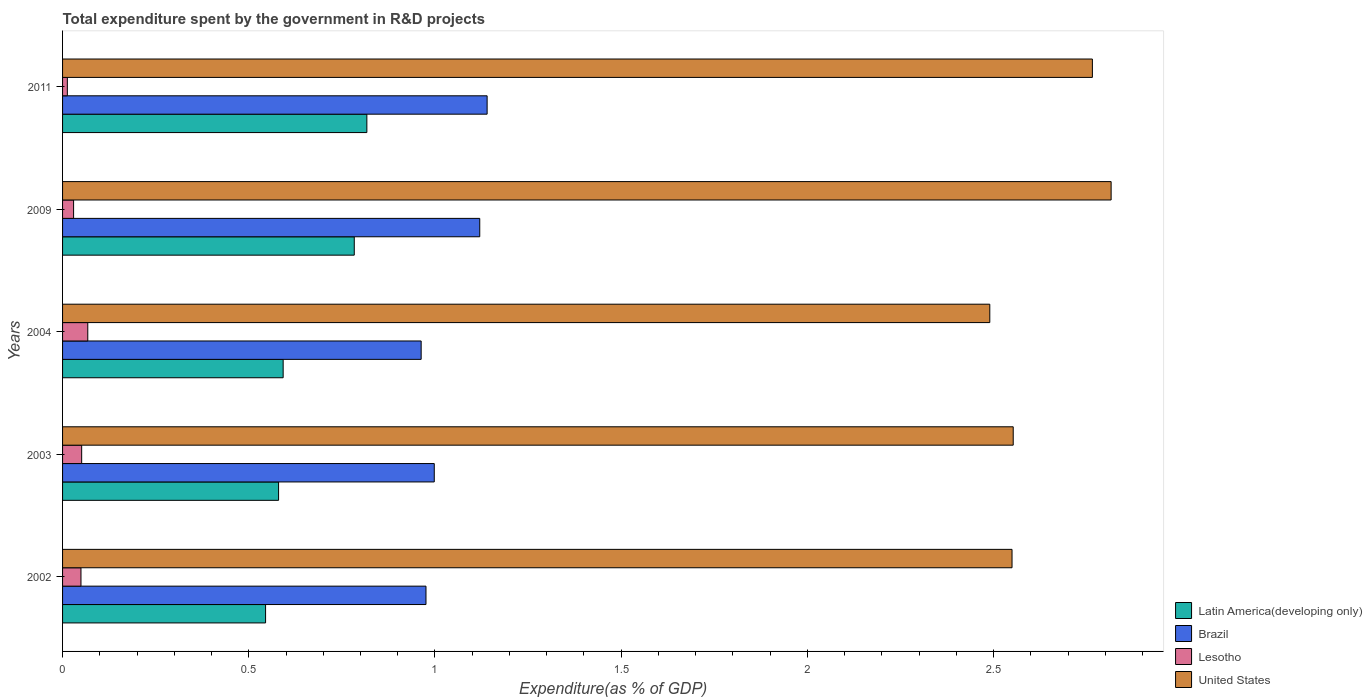How many different coloured bars are there?
Provide a short and direct response. 4. How many groups of bars are there?
Your answer should be very brief. 5. Are the number of bars per tick equal to the number of legend labels?
Offer a terse response. Yes. In how many cases, is the number of bars for a given year not equal to the number of legend labels?
Give a very brief answer. 0. What is the total expenditure spent by the government in R&D projects in Latin America(developing only) in 2004?
Provide a short and direct response. 0.59. Across all years, what is the maximum total expenditure spent by the government in R&D projects in United States?
Provide a succinct answer. 2.82. Across all years, what is the minimum total expenditure spent by the government in R&D projects in Brazil?
Offer a terse response. 0.96. In which year was the total expenditure spent by the government in R&D projects in Lesotho maximum?
Give a very brief answer. 2004. What is the total total expenditure spent by the government in R&D projects in United States in the graph?
Offer a very short reply. 13.17. What is the difference between the total expenditure spent by the government in R&D projects in United States in 2004 and that in 2011?
Your response must be concise. -0.28. What is the difference between the total expenditure spent by the government in R&D projects in United States in 2009 and the total expenditure spent by the government in R&D projects in Lesotho in 2003?
Offer a terse response. 2.76. What is the average total expenditure spent by the government in R&D projects in Brazil per year?
Make the answer very short. 1.04. In the year 2004, what is the difference between the total expenditure spent by the government in R&D projects in Brazil and total expenditure spent by the government in R&D projects in Lesotho?
Give a very brief answer. 0.9. What is the ratio of the total expenditure spent by the government in R&D projects in Brazil in 2004 to that in 2011?
Provide a succinct answer. 0.84. Is the difference between the total expenditure spent by the government in R&D projects in Brazil in 2009 and 2011 greater than the difference between the total expenditure spent by the government in R&D projects in Lesotho in 2009 and 2011?
Offer a terse response. No. What is the difference between the highest and the second highest total expenditure spent by the government in R&D projects in Lesotho?
Your response must be concise. 0.02. What is the difference between the highest and the lowest total expenditure spent by the government in R&D projects in Brazil?
Offer a very short reply. 0.18. In how many years, is the total expenditure spent by the government in R&D projects in Latin America(developing only) greater than the average total expenditure spent by the government in R&D projects in Latin America(developing only) taken over all years?
Offer a terse response. 2. Is the sum of the total expenditure spent by the government in R&D projects in Brazil in 2004 and 2011 greater than the maximum total expenditure spent by the government in R&D projects in Latin America(developing only) across all years?
Offer a terse response. Yes. What does the 3rd bar from the bottom in 2009 represents?
Your response must be concise. Lesotho. Is it the case that in every year, the sum of the total expenditure spent by the government in R&D projects in Lesotho and total expenditure spent by the government in R&D projects in United States is greater than the total expenditure spent by the government in R&D projects in Latin America(developing only)?
Offer a terse response. Yes. How many years are there in the graph?
Ensure brevity in your answer.  5. Does the graph contain any zero values?
Offer a terse response. No. Does the graph contain grids?
Make the answer very short. No. Where does the legend appear in the graph?
Your response must be concise. Bottom right. How many legend labels are there?
Provide a succinct answer. 4. How are the legend labels stacked?
Offer a terse response. Vertical. What is the title of the graph?
Provide a short and direct response. Total expenditure spent by the government in R&D projects. What is the label or title of the X-axis?
Your answer should be very brief. Expenditure(as % of GDP). What is the Expenditure(as % of GDP) in Latin America(developing only) in 2002?
Offer a very short reply. 0.55. What is the Expenditure(as % of GDP) in Brazil in 2002?
Your response must be concise. 0.98. What is the Expenditure(as % of GDP) of Lesotho in 2002?
Make the answer very short. 0.05. What is the Expenditure(as % of GDP) in United States in 2002?
Provide a succinct answer. 2.55. What is the Expenditure(as % of GDP) of Latin America(developing only) in 2003?
Offer a terse response. 0.58. What is the Expenditure(as % of GDP) in Brazil in 2003?
Make the answer very short. 1. What is the Expenditure(as % of GDP) of Lesotho in 2003?
Give a very brief answer. 0.05. What is the Expenditure(as % of GDP) of United States in 2003?
Give a very brief answer. 2.55. What is the Expenditure(as % of GDP) in Latin America(developing only) in 2004?
Offer a very short reply. 0.59. What is the Expenditure(as % of GDP) in Brazil in 2004?
Give a very brief answer. 0.96. What is the Expenditure(as % of GDP) in Lesotho in 2004?
Offer a very short reply. 0.07. What is the Expenditure(as % of GDP) in United States in 2004?
Provide a short and direct response. 2.49. What is the Expenditure(as % of GDP) in Latin America(developing only) in 2009?
Offer a terse response. 0.78. What is the Expenditure(as % of GDP) in Brazil in 2009?
Provide a succinct answer. 1.12. What is the Expenditure(as % of GDP) of Lesotho in 2009?
Provide a succinct answer. 0.03. What is the Expenditure(as % of GDP) of United States in 2009?
Your answer should be very brief. 2.82. What is the Expenditure(as % of GDP) in Latin America(developing only) in 2011?
Make the answer very short. 0.82. What is the Expenditure(as % of GDP) of Brazil in 2011?
Offer a terse response. 1.14. What is the Expenditure(as % of GDP) of Lesotho in 2011?
Your answer should be very brief. 0.01. What is the Expenditure(as % of GDP) of United States in 2011?
Your answer should be very brief. 2.77. Across all years, what is the maximum Expenditure(as % of GDP) of Latin America(developing only)?
Your answer should be very brief. 0.82. Across all years, what is the maximum Expenditure(as % of GDP) of Brazil?
Offer a terse response. 1.14. Across all years, what is the maximum Expenditure(as % of GDP) of Lesotho?
Your answer should be very brief. 0.07. Across all years, what is the maximum Expenditure(as % of GDP) of United States?
Your answer should be compact. 2.82. Across all years, what is the minimum Expenditure(as % of GDP) of Latin America(developing only)?
Offer a terse response. 0.55. Across all years, what is the minimum Expenditure(as % of GDP) of Brazil?
Provide a short and direct response. 0.96. Across all years, what is the minimum Expenditure(as % of GDP) in Lesotho?
Offer a terse response. 0.01. Across all years, what is the minimum Expenditure(as % of GDP) in United States?
Give a very brief answer. 2.49. What is the total Expenditure(as % of GDP) in Latin America(developing only) in the graph?
Make the answer very short. 3.32. What is the total Expenditure(as % of GDP) of Brazil in the graph?
Your answer should be compact. 5.2. What is the total Expenditure(as % of GDP) of Lesotho in the graph?
Offer a very short reply. 0.21. What is the total Expenditure(as % of GDP) in United States in the graph?
Ensure brevity in your answer.  13.17. What is the difference between the Expenditure(as % of GDP) in Latin America(developing only) in 2002 and that in 2003?
Offer a terse response. -0.03. What is the difference between the Expenditure(as % of GDP) of Brazil in 2002 and that in 2003?
Your answer should be very brief. -0.02. What is the difference between the Expenditure(as % of GDP) in Lesotho in 2002 and that in 2003?
Your response must be concise. -0. What is the difference between the Expenditure(as % of GDP) in United States in 2002 and that in 2003?
Your answer should be compact. -0. What is the difference between the Expenditure(as % of GDP) in Latin America(developing only) in 2002 and that in 2004?
Ensure brevity in your answer.  -0.05. What is the difference between the Expenditure(as % of GDP) of Brazil in 2002 and that in 2004?
Provide a short and direct response. 0.01. What is the difference between the Expenditure(as % of GDP) of Lesotho in 2002 and that in 2004?
Offer a very short reply. -0.02. What is the difference between the Expenditure(as % of GDP) of United States in 2002 and that in 2004?
Offer a very short reply. 0.06. What is the difference between the Expenditure(as % of GDP) of Latin America(developing only) in 2002 and that in 2009?
Your response must be concise. -0.24. What is the difference between the Expenditure(as % of GDP) of Brazil in 2002 and that in 2009?
Give a very brief answer. -0.14. What is the difference between the Expenditure(as % of GDP) of Lesotho in 2002 and that in 2009?
Your answer should be very brief. 0.02. What is the difference between the Expenditure(as % of GDP) in United States in 2002 and that in 2009?
Your answer should be very brief. -0.27. What is the difference between the Expenditure(as % of GDP) in Latin America(developing only) in 2002 and that in 2011?
Keep it short and to the point. -0.27. What is the difference between the Expenditure(as % of GDP) of Brazil in 2002 and that in 2011?
Make the answer very short. -0.16. What is the difference between the Expenditure(as % of GDP) of Lesotho in 2002 and that in 2011?
Offer a very short reply. 0.04. What is the difference between the Expenditure(as % of GDP) in United States in 2002 and that in 2011?
Your response must be concise. -0.22. What is the difference between the Expenditure(as % of GDP) of Latin America(developing only) in 2003 and that in 2004?
Keep it short and to the point. -0.01. What is the difference between the Expenditure(as % of GDP) in Brazil in 2003 and that in 2004?
Give a very brief answer. 0.04. What is the difference between the Expenditure(as % of GDP) of Lesotho in 2003 and that in 2004?
Provide a short and direct response. -0.02. What is the difference between the Expenditure(as % of GDP) of United States in 2003 and that in 2004?
Your answer should be compact. 0.06. What is the difference between the Expenditure(as % of GDP) of Latin America(developing only) in 2003 and that in 2009?
Keep it short and to the point. -0.2. What is the difference between the Expenditure(as % of GDP) of Brazil in 2003 and that in 2009?
Your answer should be very brief. -0.12. What is the difference between the Expenditure(as % of GDP) of Lesotho in 2003 and that in 2009?
Provide a short and direct response. 0.02. What is the difference between the Expenditure(as % of GDP) in United States in 2003 and that in 2009?
Keep it short and to the point. -0.26. What is the difference between the Expenditure(as % of GDP) of Latin America(developing only) in 2003 and that in 2011?
Keep it short and to the point. -0.24. What is the difference between the Expenditure(as % of GDP) of Brazil in 2003 and that in 2011?
Give a very brief answer. -0.14. What is the difference between the Expenditure(as % of GDP) in Lesotho in 2003 and that in 2011?
Ensure brevity in your answer.  0.04. What is the difference between the Expenditure(as % of GDP) of United States in 2003 and that in 2011?
Provide a short and direct response. -0.21. What is the difference between the Expenditure(as % of GDP) of Latin America(developing only) in 2004 and that in 2009?
Provide a short and direct response. -0.19. What is the difference between the Expenditure(as % of GDP) in Brazil in 2004 and that in 2009?
Give a very brief answer. -0.16. What is the difference between the Expenditure(as % of GDP) in Lesotho in 2004 and that in 2009?
Provide a succinct answer. 0.04. What is the difference between the Expenditure(as % of GDP) in United States in 2004 and that in 2009?
Your response must be concise. -0.33. What is the difference between the Expenditure(as % of GDP) in Latin America(developing only) in 2004 and that in 2011?
Make the answer very short. -0.22. What is the difference between the Expenditure(as % of GDP) of Brazil in 2004 and that in 2011?
Provide a short and direct response. -0.18. What is the difference between the Expenditure(as % of GDP) in Lesotho in 2004 and that in 2011?
Make the answer very short. 0.05. What is the difference between the Expenditure(as % of GDP) in United States in 2004 and that in 2011?
Provide a short and direct response. -0.28. What is the difference between the Expenditure(as % of GDP) in Latin America(developing only) in 2009 and that in 2011?
Offer a terse response. -0.03. What is the difference between the Expenditure(as % of GDP) of Brazil in 2009 and that in 2011?
Provide a short and direct response. -0.02. What is the difference between the Expenditure(as % of GDP) in Lesotho in 2009 and that in 2011?
Make the answer very short. 0.02. What is the difference between the Expenditure(as % of GDP) of United States in 2009 and that in 2011?
Offer a terse response. 0.05. What is the difference between the Expenditure(as % of GDP) in Latin America(developing only) in 2002 and the Expenditure(as % of GDP) in Brazil in 2003?
Your answer should be compact. -0.45. What is the difference between the Expenditure(as % of GDP) of Latin America(developing only) in 2002 and the Expenditure(as % of GDP) of Lesotho in 2003?
Offer a very short reply. 0.49. What is the difference between the Expenditure(as % of GDP) of Latin America(developing only) in 2002 and the Expenditure(as % of GDP) of United States in 2003?
Ensure brevity in your answer.  -2.01. What is the difference between the Expenditure(as % of GDP) in Brazil in 2002 and the Expenditure(as % of GDP) in Lesotho in 2003?
Provide a short and direct response. 0.92. What is the difference between the Expenditure(as % of GDP) of Brazil in 2002 and the Expenditure(as % of GDP) of United States in 2003?
Offer a terse response. -1.58. What is the difference between the Expenditure(as % of GDP) in Lesotho in 2002 and the Expenditure(as % of GDP) in United States in 2003?
Provide a succinct answer. -2.5. What is the difference between the Expenditure(as % of GDP) of Latin America(developing only) in 2002 and the Expenditure(as % of GDP) of Brazil in 2004?
Provide a short and direct response. -0.42. What is the difference between the Expenditure(as % of GDP) in Latin America(developing only) in 2002 and the Expenditure(as % of GDP) in Lesotho in 2004?
Make the answer very short. 0.48. What is the difference between the Expenditure(as % of GDP) in Latin America(developing only) in 2002 and the Expenditure(as % of GDP) in United States in 2004?
Offer a terse response. -1.94. What is the difference between the Expenditure(as % of GDP) in Brazil in 2002 and the Expenditure(as % of GDP) in Lesotho in 2004?
Give a very brief answer. 0.91. What is the difference between the Expenditure(as % of GDP) of Brazil in 2002 and the Expenditure(as % of GDP) of United States in 2004?
Your answer should be very brief. -1.51. What is the difference between the Expenditure(as % of GDP) of Lesotho in 2002 and the Expenditure(as % of GDP) of United States in 2004?
Your response must be concise. -2.44. What is the difference between the Expenditure(as % of GDP) of Latin America(developing only) in 2002 and the Expenditure(as % of GDP) of Brazil in 2009?
Provide a short and direct response. -0.58. What is the difference between the Expenditure(as % of GDP) of Latin America(developing only) in 2002 and the Expenditure(as % of GDP) of Lesotho in 2009?
Your answer should be very brief. 0.52. What is the difference between the Expenditure(as % of GDP) of Latin America(developing only) in 2002 and the Expenditure(as % of GDP) of United States in 2009?
Provide a succinct answer. -2.27. What is the difference between the Expenditure(as % of GDP) of Brazil in 2002 and the Expenditure(as % of GDP) of Lesotho in 2009?
Your answer should be compact. 0.95. What is the difference between the Expenditure(as % of GDP) of Brazil in 2002 and the Expenditure(as % of GDP) of United States in 2009?
Offer a very short reply. -1.84. What is the difference between the Expenditure(as % of GDP) of Lesotho in 2002 and the Expenditure(as % of GDP) of United States in 2009?
Make the answer very short. -2.77. What is the difference between the Expenditure(as % of GDP) in Latin America(developing only) in 2002 and the Expenditure(as % of GDP) in Brazil in 2011?
Your response must be concise. -0.59. What is the difference between the Expenditure(as % of GDP) of Latin America(developing only) in 2002 and the Expenditure(as % of GDP) of Lesotho in 2011?
Your answer should be very brief. 0.53. What is the difference between the Expenditure(as % of GDP) in Latin America(developing only) in 2002 and the Expenditure(as % of GDP) in United States in 2011?
Your response must be concise. -2.22. What is the difference between the Expenditure(as % of GDP) of Brazil in 2002 and the Expenditure(as % of GDP) of Lesotho in 2011?
Offer a very short reply. 0.96. What is the difference between the Expenditure(as % of GDP) in Brazil in 2002 and the Expenditure(as % of GDP) in United States in 2011?
Make the answer very short. -1.79. What is the difference between the Expenditure(as % of GDP) of Lesotho in 2002 and the Expenditure(as % of GDP) of United States in 2011?
Your answer should be compact. -2.72. What is the difference between the Expenditure(as % of GDP) in Latin America(developing only) in 2003 and the Expenditure(as % of GDP) in Brazil in 2004?
Make the answer very short. -0.38. What is the difference between the Expenditure(as % of GDP) of Latin America(developing only) in 2003 and the Expenditure(as % of GDP) of Lesotho in 2004?
Your response must be concise. 0.51. What is the difference between the Expenditure(as % of GDP) of Latin America(developing only) in 2003 and the Expenditure(as % of GDP) of United States in 2004?
Your response must be concise. -1.91. What is the difference between the Expenditure(as % of GDP) of Brazil in 2003 and the Expenditure(as % of GDP) of Lesotho in 2004?
Your answer should be very brief. 0.93. What is the difference between the Expenditure(as % of GDP) of Brazil in 2003 and the Expenditure(as % of GDP) of United States in 2004?
Ensure brevity in your answer.  -1.49. What is the difference between the Expenditure(as % of GDP) of Lesotho in 2003 and the Expenditure(as % of GDP) of United States in 2004?
Make the answer very short. -2.44. What is the difference between the Expenditure(as % of GDP) of Latin America(developing only) in 2003 and the Expenditure(as % of GDP) of Brazil in 2009?
Ensure brevity in your answer.  -0.54. What is the difference between the Expenditure(as % of GDP) in Latin America(developing only) in 2003 and the Expenditure(as % of GDP) in Lesotho in 2009?
Your answer should be very brief. 0.55. What is the difference between the Expenditure(as % of GDP) in Latin America(developing only) in 2003 and the Expenditure(as % of GDP) in United States in 2009?
Your answer should be very brief. -2.24. What is the difference between the Expenditure(as % of GDP) in Brazil in 2003 and the Expenditure(as % of GDP) in Lesotho in 2009?
Provide a short and direct response. 0.97. What is the difference between the Expenditure(as % of GDP) of Brazil in 2003 and the Expenditure(as % of GDP) of United States in 2009?
Offer a terse response. -1.82. What is the difference between the Expenditure(as % of GDP) of Lesotho in 2003 and the Expenditure(as % of GDP) of United States in 2009?
Provide a succinct answer. -2.76. What is the difference between the Expenditure(as % of GDP) of Latin America(developing only) in 2003 and the Expenditure(as % of GDP) of Brazil in 2011?
Ensure brevity in your answer.  -0.56. What is the difference between the Expenditure(as % of GDP) in Latin America(developing only) in 2003 and the Expenditure(as % of GDP) in Lesotho in 2011?
Keep it short and to the point. 0.57. What is the difference between the Expenditure(as % of GDP) in Latin America(developing only) in 2003 and the Expenditure(as % of GDP) in United States in 2011?
Your response must be concise. -2.19. What is the difference between the Expenditure(as % of GDP) of Brazil in 2003 and the Expenditure(as % of GDP) of Lesotho in 2011?
Provide a succinct answer. 0.99. What is the difference between the Expenditure(as % of GDP) in Brazil in 2003 and the Expenditure(as % of GDP) in United States in 2011?
Offer a terse response. -1.77. What is the difference between the Expenditure(as % of GDP) of Lesotho in 2003 and the Expenditure(as % of GDP) of United States in 2011?
Your response must be concise. -2.71. What is the difference between the Expenditure(as % of GDP) in Latin America(developing only) in 2004 and the Expenditure(as % of GDP) in Brazil in 2009?
Offer a terse response. -0.53. What is the difference between the Expenditure(as % of GDP) of Latin America(developing only) in 2004 and the Expenditure(as % of GDP) of Lesotho in 2009?
Give a very brief answer. 0.56. What is the difference between the Expenditure(as % of GDP) in Latin America(developing only) in 2004 and the Expenditure(as % of GDP) in United States in 2009?
Provide a succinct answer. -2.22. What is the difference between the Expenditure(as % of GDP) of Brazil in 2004 and the Expenditure(as % of GDP) of Lesotho in 2009?
Give a very brief answer. 0.93. What is the difference between the Expenditure(as % of GDP) of Brazil in 2004 and the Expenditure(as % of GDP) of United States in 2009?
Provide a short and direct response. -1.85. What is the difference between the Expenditure(as % of GDP) of Lesotho in 2004 and the Expenditure(as % of GDP) of United States in 2009?
Provide a short and direct response. -2.75. What is the difference between the Expenditure(as % of GDP) of Latin America(developing only) in 2004 and the Expenditure(as % of GDP) of Brazil in 2011?
Keep it short and to the point. -0.55. What is the difference between the Expenditure(as % of GDP) of Latin America(developing only) in 2004 and the Expenditure(as % of GDP) of Lesotho in 2011?
Ensure brevity in your answer.  0.58. What is the difference between the Expenditure(as % of GDP) in Latin America(developing only) in 2004 and the Expenditure(as % of GDP) in United States in 2011?
Offer a terse response. -2.17. What is the difference between the Expenditure(as % of GDP) in Brazil in 2004 and the Expenditure(as % of GDP) in Lesotho in 2011?
Your answer should be very brief. 0.95. What is the difference between the Expenditure(as % of GDP) in Brazil in 2004 and the Expenditure(as % of GDP) in United States in 2011?
Ensure brevity in your answer.  -1.8. What is the difference between the Expenditure(as % of GDP) of Lesotho in 2004 and the Expenditure(as % of GDP) of United States in 2011?
Ensure brevity in your answer.  -2.7. What is the difference between the Expenditure(as % of GDP) in Latin America(developing only) in 2009 and the Expenditure(as % of GDP) in Brazil in 2011?
Give a very brief answer. -0.36. What is the difference between the Expenditure(as % of GDP) of Latin America(developing only) in 2009 and the Expenditure(as % of GDP) of Lesotho in 2011?
Your answer should be very brief. 0.77. What is the difference between the Expenditure(as % of GDP) of Latin America(developing only) in 2009 and the Expenditure(as % of GDP) of United States in 2011?
Offer a terse response. -1.98. What is the difference between the Expenditure(as % of GDP) of Brazil in 2009 and the Expenditure(as % of GDP) of Lesotho in 2011?
Ensure brevity in your answer.  1.11. What is the difference between the Expenditure(as % of GDP) in Brazil in 2009 and the Expenditure(as % of GDP) in United States in 2011?
Keep it short and to the point. -1.65. What is the difference between the Expenditure(as % of GDP) of Lesotho in 2009 and the Expenditure(as % of GDP) of United States in 2011?
Your response must be concise. -2.74. What is the average Expenditure(as % of GDP) of Latin America(developing only) per year?
Make the answer very short. 0.66. What is the average Expenditure(as % of GDP) of Brazil per year?
Offer a very short reply. 1.04. What is the average Expenditure(as % of GDP) in Lesotho per year?
Give a very brief answer. 0.04. What is the average Expenditure(as % of GDP) of United States per year?
Give a very brief answer. 2.63. In the year 2002, what is the difference between the Expenditure(as % of GDP) in Latin America(developing only) and Expenditure(as % of GDP) in Brazil?
Offer a very short reply. -0.43. In the year 2002, what is the difference between the Expenditure(as % of GDP) in Latin America(developing only) and Expenditure(as % of GDP) in Lesotho?
Ensure brevity in your answer.  0.5. In the year 2002, what is the difference between the Expenditure(as % of GDP) of Latin America(developing only) and Expenditure(as % of GDP) of United States?
Your response must be concise. -2. In the year 2002, what is the difference between the Expenditure(as % of GDP) in Brazil and Expenditure(as % of GDP) in Lesotho?
Your answer should be compact. 0.93. In the year 2002, what is the difference between the Expenditure(as % of GDP) of Brazil and Expenditure(as % of GDP) of United States?
Provide a short and direct response. -1.57. In the year 2002, what is the difference between the Expenditure(as % of GDP) in Lesotho and Expenditure(as % of GDP) in United States?
Your answer should be very brief. -2.5. In the year 2003, what is the difference between the Expenditure(as % of GDP) in Latin America(developing only) and Expenditure(as % of GDP) in Brazil?
Provide a succinct answer. -0.42. In the year 2003, what is the difference between the Expenditure(as % of GDP) in Latin America(developing only) and Expenditure(as % of GDP) in Lesotho?
Ensure brevity in your answer.  0.53. In the year 2003, what is the difference between the Expenditure(as % of GDP) in Latin America(developing only) and Expenditure(as % of GDP) in United States?
Make the answer very short. -1.97. In the year 2003, what is the difference between the Expenditure(as % of GDP) of Brazil and Expenditure(as % of GDP) of Lesotho?
Make the answer very short. 0.95. In the year 2003, what is the difference between the Expenditure(as % of GDP) in Brazil and Expenditure(as % of GDP) in United States?
Keep it short and to the point. -1.55. In the year 2003, what is the difference between the Expenditure(as % of GDP) of Lesotho and Expenditure(as % of GDP) of United States?
Offer a very short reply. -2.5. In the year 2004, what is the difference between the Expenditure(as % of GDP) in Latin America(developing only) and Expenditure(as % of GDP) in Brazil?
Keep it short and to the point. -0.37. In the year 2004, what is the difference between the Expenditure(as % of GDP) in Latin America(developing only) and Expenditure(as % of GDP) in Lesotho?
Provide a succinct answer. 0.52. In the year 2004, what is the difference between the Expenditure(as % of GDP) of Latin America(developing only) and Expenditure(as % of GDP) of United States?
Offer a terse response. -1.9. In the year 2004, what is the difference between the Expenditure(as % of GDP) in Brazil and Expenditure(as % of GDP) in Lesotho?
Offer a very short reply. 0.9. In the year 2004, what is the difference between the Expenditure(as % of GDP) of Brazil and Expenditure(as % of GDP) of United States?
Ensure brevity in your answer.  -1.53. In the year 2004, what is the difference between the Expenditure(as % of GDP) in Lesotho and Expenditure(as % of GDP) in United States?
Make the answer very short. -2.42. In the year 2009, what is the difference between the Expenditure(as % of GDP) in Latin America(developing only) and Expenditure(as % of GDP) in Brazil?
Ensure brevity in your answer.  -0.34. In the year 2009, what is the difference between the Expenditure(as % of GDP) of Latin America(developing only) and Expenditure(as % of GDP) of Lesotho?
Offer a terse response. 0.75. In the year 2009, what is the difference between the Expenditure(as % of GDP) in Latin America(developing only) and Expenditure(as % of GDP) in United States?
Your answer should be very brief. -2.03. In the year 2009, what is the difference between the Expenditure(as % of GDP) of Brazil and Expenditure(as % of GDP) of Lesotho?
Provide a succinct answer. 1.09. In the year 2009, what is the difference between the Expenditure(as % of GDP) in Brazil and Expenditure(as % of GDP) in United States?
Keep it short and to the point. -1.7. In the year 2009, what is the difference between the Expenditure(as % of GDP) in Lesotho and Expenditure(as % of GDP) in United States?
Offer a terse response. -2.79. In the year 2011, what is the difference between the Expenditure(as % of GDP) of Latin America(developing only) and Expenditure(as % of GDP) of Brazil?
Your response must be concise. -0.32. In the year 2011, what is the difference between the Expenditure(as % of GDP) in Latin America(developing only) and Expenditure(as % of GDP) in Lesotho?
Ensure brevity in your answer.  0.8. In the year 2011, what is the difference between the Expenditure(as % of GDP) of Latin America(developing only) and Expenditure(as % of GDP) of United States?
Provide a short and direct response. -1.95. In the year 2011, what is the difference between the Expenditure(as % of GDP) of Brazil and Expenditure(as % of GDP) of Lesotho?
Ensure brevity in your answer.  1.13. In the year 2011, what is the difference between the Expenditure(as % of GDP) of Brazil and Expenditure(as % of GDP) of United States?
Your answer should be compact. -1.63. In the year 2011, what is the difference between the Expenditure(as % of GDP) of Lesotho and Expenditure(as % of GDP) of United States?
Offer a very short reply. -2.75. What is the ratio of the Expenditure(as % of GDP) in Latin America(developing only) in 2002 to that in 2003?
Keep it short and to the point. 0.94. What is the ratio of the Expenditure(as % of GDP) in Brazil in 2002 to that in 2003?
Your response must be concise. 0.98. What is the ratio of the Expenditure(as % of GDP) of Lesotho in 2002 to that in 2003?
Provide a succinct answer. 0.96. What is the ratio of the Expenditure(as % of GDP) in United States in 2002 to that in 2003?
Your answer should be compact. 1. What is the ratio of the Expenditure(as % of GDP) of Latin America(developing only) in 2002 to that in 2004?
Offer a very short reply. 0.92. What is the ratio of the Expenditure(as % of GDP) in Brazil in 2002 to that in 2004?
Offer a very short reply. 1.01. What is the ratio of the Expenditure(as % of GDP) in Lesotho in 2002 to that in 2004?
Keep it short and to the point. 0.73. What is the ratio of the Expenditure(as % of GDP) of United States in 2002 to that in 2004?
Your answer should be very brief. 1.02. What is the ratio of the Expenditure(as % of GDP) of Latin America(developing only) in 2002 to that in 2009?
Your answer should be very brief. 0.7. What is the ratio of the Expenditure(as % of GDP) of Brazil in 2002 to that in 2009?
Keep it short and to the point. 0.87. What is the ratio of the Expenditure(as % of GDP) of Lesotho in 2002 to that in 2009?
Offer a terse response. 1.67. What is the ratio of the Expenditure(as % of GDP) of United States in 2002 to that in 2009?
Provide a succinct answer. 0.91. What is the ratio of the Expenditure(as % of GDP) in Latin America(developing only) in 2002 to that in 2011?
Provide a succinct answer. 0.67. What is the ratio of the Expenditure(as % of GDP) of Brazil in 2002 to that in 2011?
Offer a terse response. 0.86. What is the ratio of the Expenditure(as % of GDP) of Lesotho in 2002 to that in 2011?
Provide a short and direct response. 3.85. What is the ratio of the Expenditure(as % of GDP) in United States in 2002 to that in 2011?
Make the answer very short. 0.92. What is the ratio of the Expenditure(as % of GDP) of Latin America(developing only) in 2003 to that in 2004?
Provide a short and direct response. 0.98. What is the ratio of the Expenditure(as % of GDP) in Brazil in 2003 to that in 2004?
Ensure brevity in your answer.  1.04. What is the ratio of the Expenditure(as % of GDP) in Lesotho in 2003 to that in 2004?
Your answer should be very brief. 0.76. What is the ratio of the Expenditure(as % of GDP) in United States in 2003 to that in 2004?
Offer a very short reply. 1.03. What is the ratio of the Expenditure(as % of GDP) in Latin America(developing only) in 2003 to that in 2009?
Your answer should be compact. 0.74. What is the ratio of the Expenditure(as % of GDP) of Brazil in 2003 to that in 2009?
Your response must be concise. 0.89. What is the ratio of the Expenditure(as % of GDP) in Lesotho in 2003 to that in 2009?
Provide a short and direct response. 1.73. What is the ratio of the Expenditure(as % of GDP) in United States in 2003 to that in 2009?
Ensure brevity in your answer.  0.91. What is the ratio of the Expenditure(as % of GDP) in Latin America(developing only) in 2003 to that in 2011?
Make the answer very short. 0.71. What is the ratio of the Expenditure(as % of GDP) in Brazil in 2003 to that in 2011?
Your response must be concise. 0.88. What is the ratio of the Expenditure(as % of GDP) of Lesotho in 2003 to that in 2011?
Ensure brevity in your answer.  4. What is the ratio of the Expenditure(as % of GDP) of United States in 2003 to that in 2011?
Your response must be concise. 0.92. What is the ratio of the Expenditure(as % of GDP) of Latin America(developing only) in 2004 to that in 2009?
Give a very brief answer. 0.76. What is the ratio of the Expenditure(as % of GDP) in Brazil in 2004 to that in 2009?
Offer a terse response. 0.86. What is the ratio of the Expenditure(as % of GDP) of Lesotho in 2004 to that in 2009?
Make the answer very short. 2.29. What is the ratio of the Expenditure(as % of GDP) in United States in 2004 to that in 2009?
Offer a terse response. 0.88. What is the ratio of the Expenditure(as % of GDP) of Latin America(developing only) in 2004 to that in 2011?
Offer a terse response. 0.72. What is the ratio of the Expenditure(as % of GDP) in Brazil in 2004 to that in 2011?
Make the answer very short. 0.84. What is the ratio of the Expenditure(as % of GDP) in Lesotho in 2004 to that in 2011?
Your answer should be very brief. 5.28. What is the ratio of the Expenditure(as % of GDP) of United States in 2004 to that in 2011?
Ensure brevity in your answer.  0.9. What is the ratio of the Expenditure(as % of GDP) of Latin America(developing only) in 2009 to that in 2011?
Offer a very short reply. 0.96. What is the ratio of the Expenditure(as % of GDP) in Brazil in 2009 to that in 2011?
Provide a short and direct response. 0.98. What is the ratio of the Expenditure(as % of GDP) of Lesotho in 2009 to that in 2011?
Offer a terse response. 2.31. What is the ratio of the Expenditure(as % of GDP) in United States in 2009 to that in 2011?
Offer a terse response. 1.02. What is the difference between the highest and the second highest Expenditure(as % of GDP) in Latin America(developing only)?
Give a very brief answer. 0.03. What is the difference between the highest and the second highest Expenditure(as % of GDP) in Brazil?
Make the answer very short. 0.02. What is the difference between the highest and the second highest Expenditure(as % of GDP) in Lesotho?
Make the answer very short. 0.02. What is the difference between the highest and the second highest Expenditure(as % of GDP) of United States?
Your response must be concise. 0.05. What is the difference between the highest and the lowest Expenditure(as % of GDP) of Latin America(developing only)?
Ensure brevity in your answer.  0.27. What is the difference between the highest and the lowest Expenditure(as % of GDP) in Brazil?
Ensure brevity in your answer.  0.18. What is the difference between the highest and the lowest Expenditure(as % of GDP) in Lesotho?
Provide a short and direct response. 0.05. What is the difference between the highest and the lowest Expenditure(as % of GDP) of United States?
Provide a short and direct response. 0.33. 